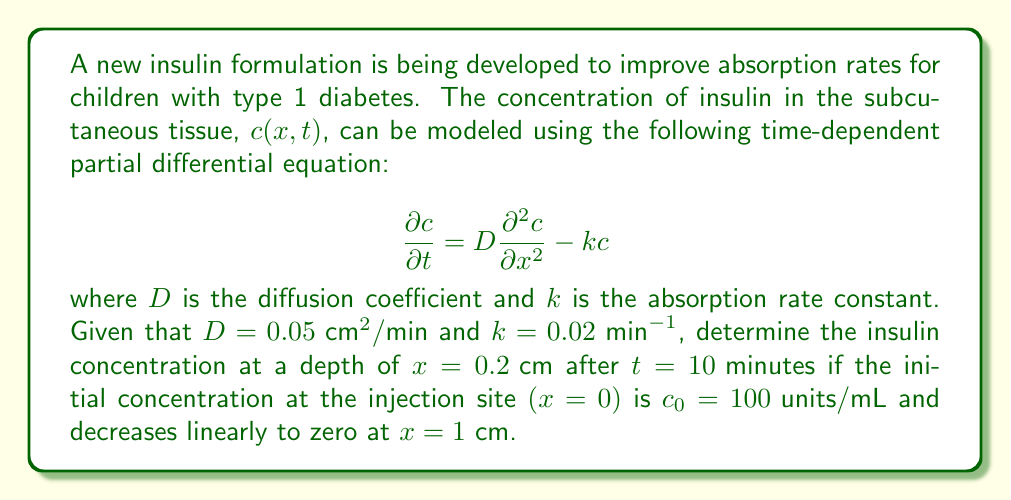Help me with this question. To solve this problem, we need to use the analytical solution for the given partial differential equation with the specified initial and boundary conditions. The solution for this type of problem is given by:

$$c(x,t) = c_0 (1 - \frac{x}{L}) e^{-kt} \text{erfc}\left(\frac{x}{2\sqrt{Dt}}\right)$$

where $L$ is the length over which the concentration decreases to zero (in this case, $L = 1 \text{ cm}$), and erfc is the complementary error function.

Let's substitute the given values:

$x = 0.2 \text{ cm}$
$t = 10 \text{ min}$
$D = 0.05 \text{ cm}^2/\text{min}$
$k = 0.02 \text{ min}^{-1}$
$c_0 = 100 \text{ units/mL}$
$L = 1 \text{ cm}$

Now, let's calculate step by step:

1) First, calculate $\frac{x}{2\sqrt{Dt}}$:
   $$\frac{0.2}{2\sqrt{0.05 \cdot 10}} = 0.2$$

2) Find erfc(0.2) using a calculator or error function table:
   erfc(0.2) ≈ 0.7773

3) Calculate $e^{-kt}$:
   $$e^{-0.02 \cdot 10} = e^{-0.2} \approx 0.8187$$

4) Calculate $(1 - \frac{x}{L})$:
   $$1 - \frac{0.2}{1} = 0.8$$

5) Now, substitute all these values into the main equation:

   $$c(0.2, 10) = 100 \cdot 0.8 \cdot 0.8187 \cdot 0.7773$$

6) Compute the final result:
   $$c(0.2, 10) \approx 50.96 \text{ units/mL}$$
Answer: The insulin concentration at a depth of 0.2 cm after 10 minutes is approximately 50.96 units/mL. 